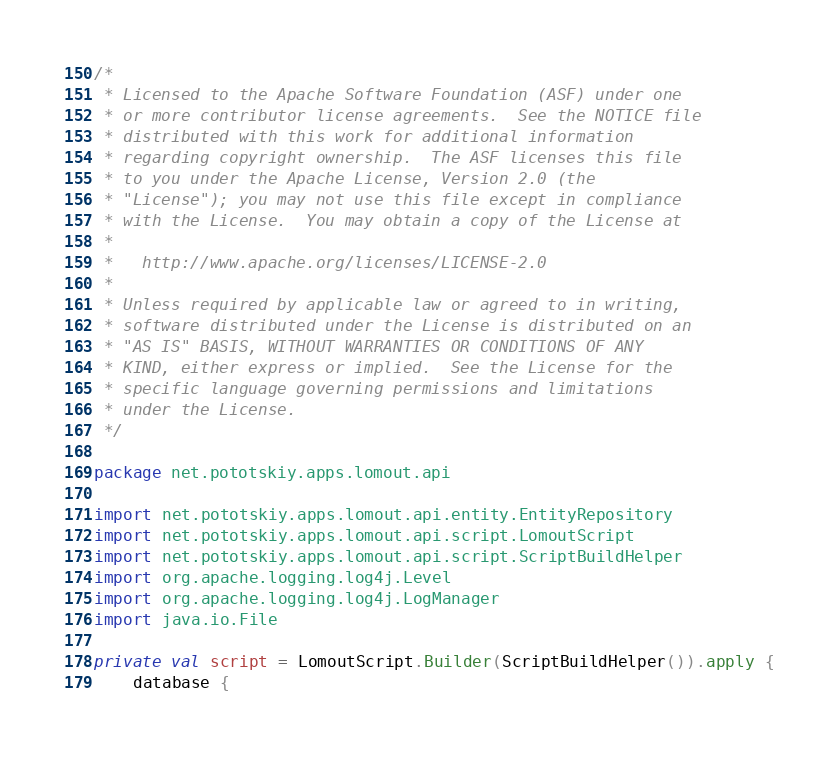<code> <loc_0><loc_0><loc_500><loc_500><_Kotlin_>/*
 * Licensed to the Apache Software Foundation (ASF) under one
 * or more contributor license agreements.  See the NOTICE file
 * distributed with this work for additional information
 * regarding copyright ownership.  The ASF licenses this file
 * to you under the Apache License, Version 2.0 (the
 * "License"); you may not use this file except in compliance
 * with the License.  You may obtain a copy of the License at
 *
 *   http://www.apache.org/licenses/LICENSE-2.0
 *
 * Unless required by applicable law or agreed to in writing,
 * software distributed under the License is distributed on an
 * "AS IS" BASIS, WITHOUT WARRANTIES OR CONDITIONS OF ANY
 * KIND, either express or implied.  See the License for the
 * specific language governing permissions and limitations
 * under the License.
 */

package net.pototskiy.apps.lomout.api

import net.pototskiy.apps.lomout.api.entity.EntityRepository
import net.pototskiy.apps.lomout.api.script.LomoutScript
import net.pototskiy.apps.lomout.api.script.ScriptBuildHelper
import org.apache.logging.log4j.Level
import org.apache.logging.log4j.LogManager
import java.io.File

private val script = LomoutScript.Builder(ScriptBuildHelper()).apply {
    database {</code> 